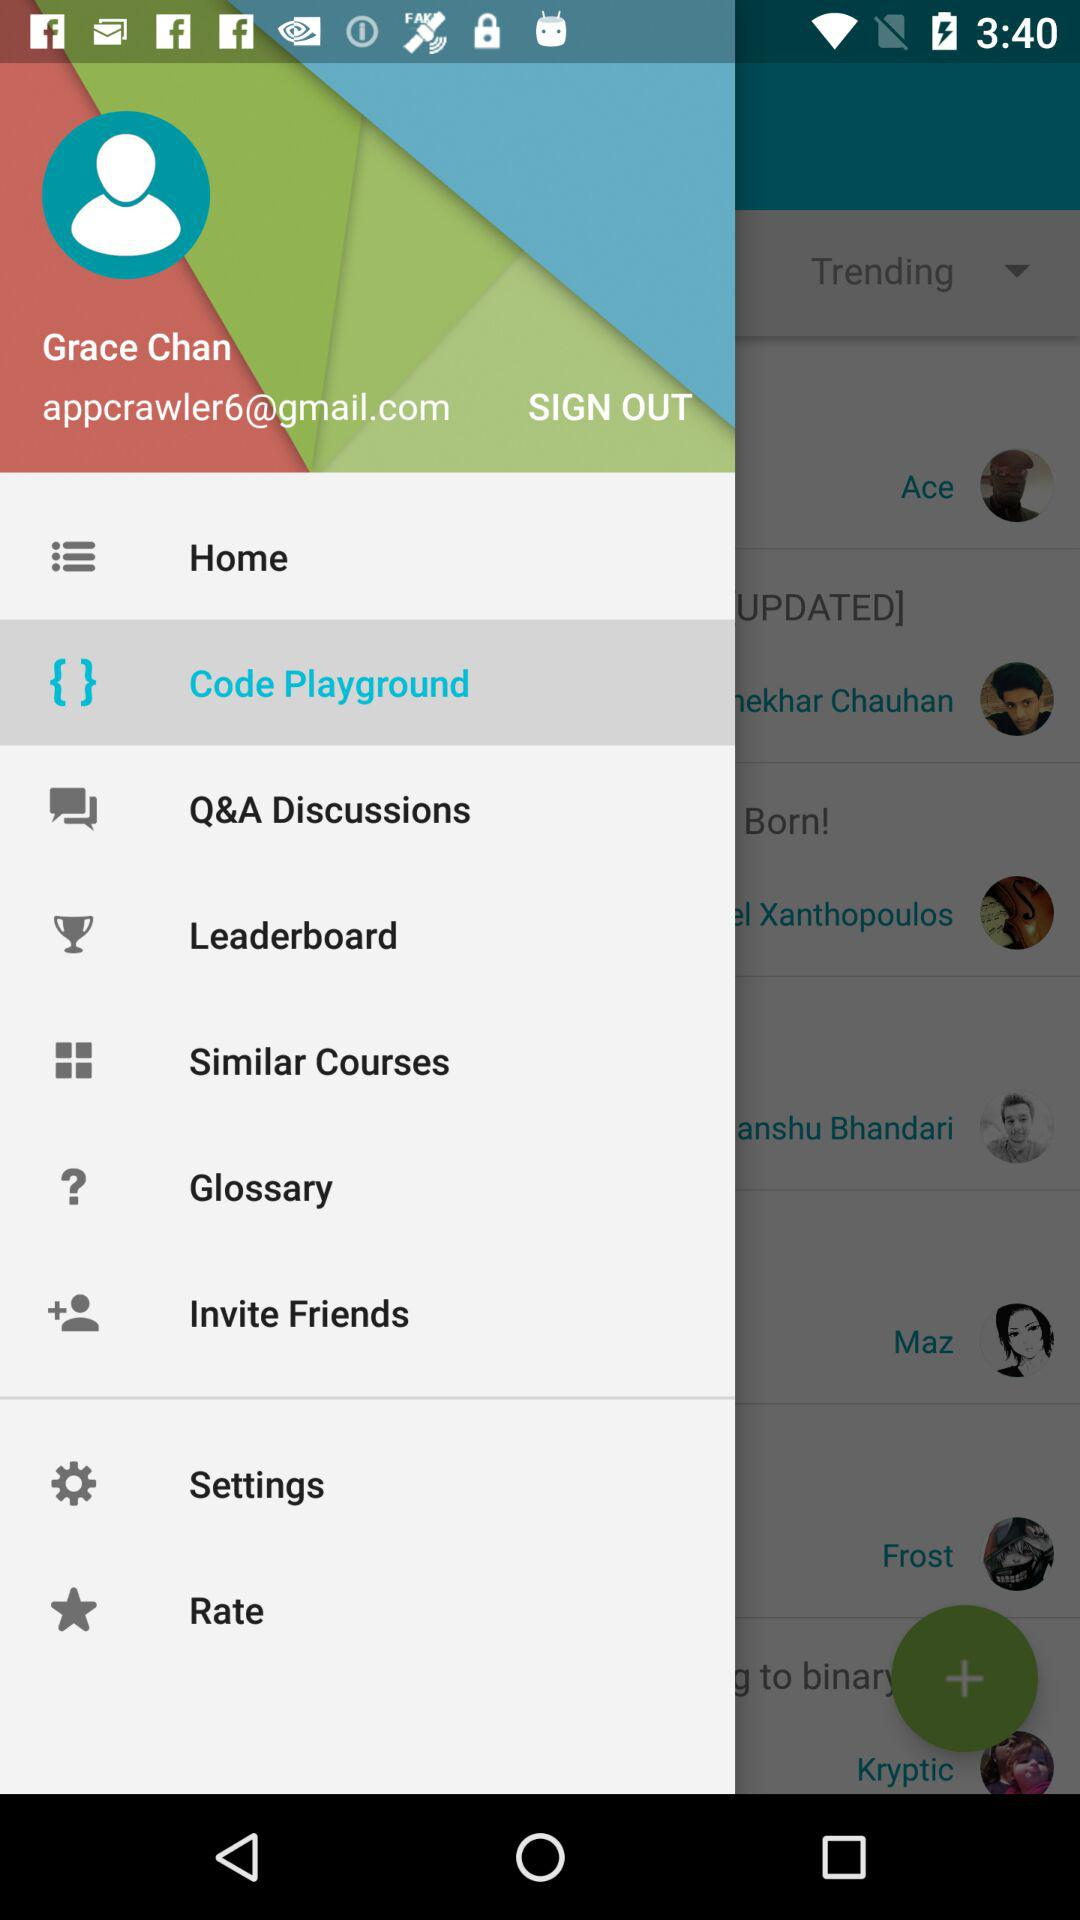What is the name of the user? The name of the user is Grace Chan. 